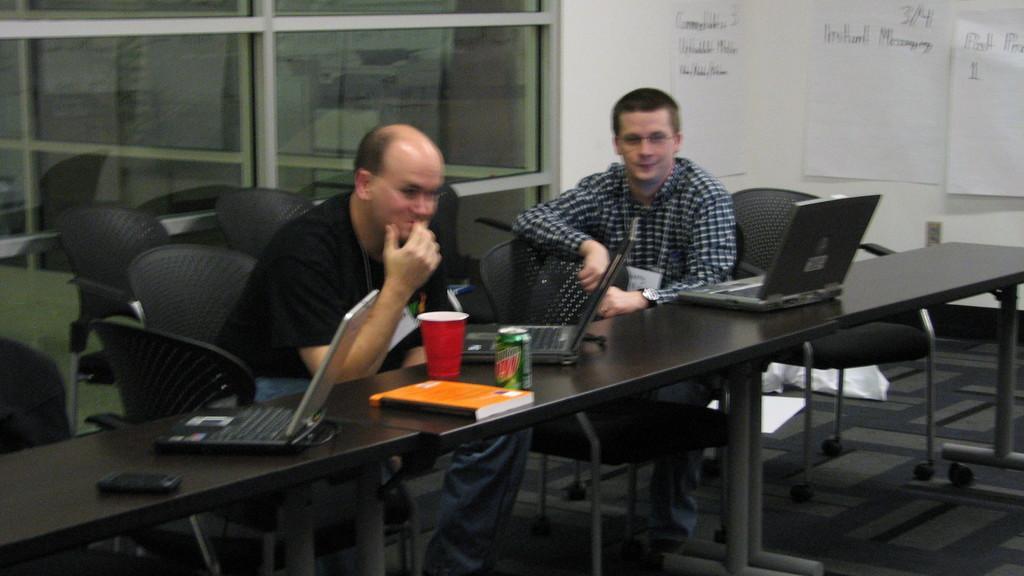Can you describe this image briefly? In this image there are two men sitting on the chair in front of the table. On the table there are three laptops,cup,book,mobile and tin. At the background there are glass windows and stickers. 